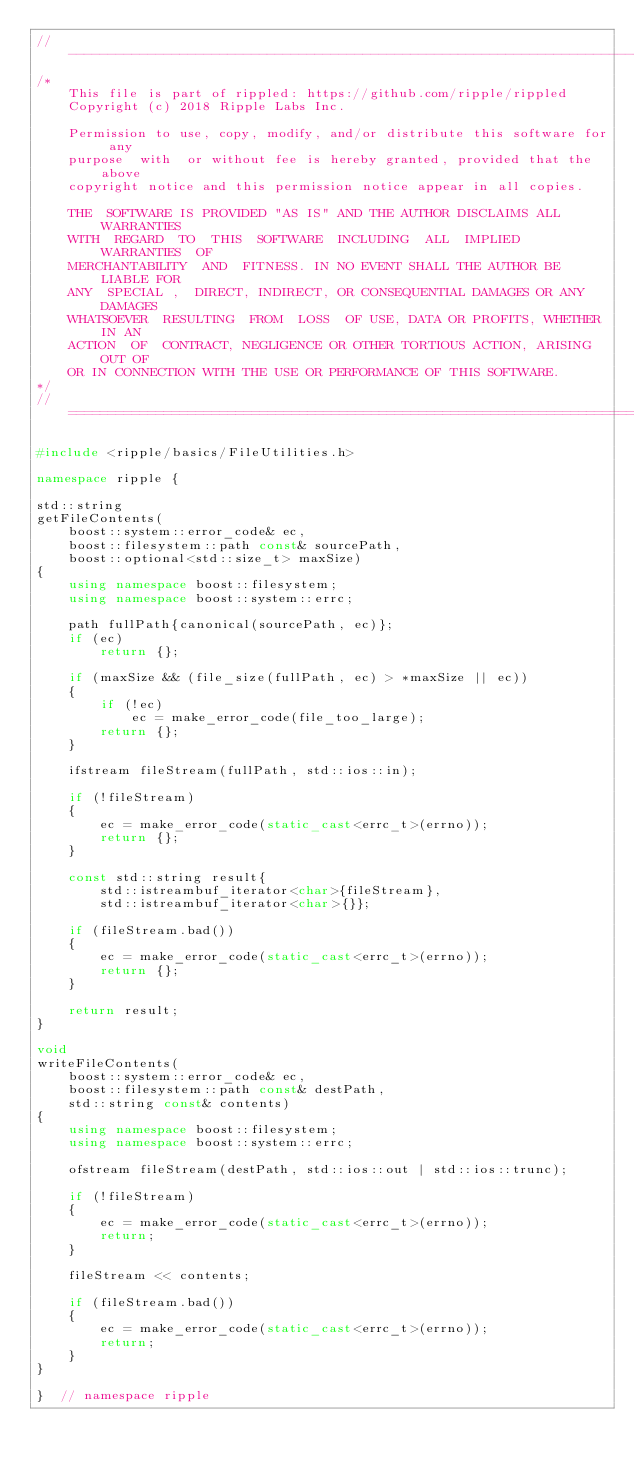<code> <loc_0><loc_0><loc_500><loc_500><_C++_>//------------------------------------------------------------------------------
/*
    This file is part of rippled: https://github.com/ripple/rippled
    Copyright (c) 2018 Ripple Labs Inc.

    Permission to use, copy, modify, and/or distribute this software for any
    purpose  with  or without fee is hereby granted, provided that the above
    copyright notice and this permission notice appear in all copies.

    THE  SOFTWARE IS PROVIDED "AS IS" AND THE AUTHOR DISCLAIMS ALL WARRANTIES
    WITH  REGARD  TO  THIS  SOFTWARE  INCLUDING  ALL  IMPLIED  WARRANTIES  OF
    MERCHANTABILITY  AND  FITNESS. IN NO EVENT SHALL THE AUTHOR BE LIABLE FOR
    ANY  SPECIAL ,  DIRECT, INDIRECT, OR CONSEQUENTIAL DAMAGES OR ANY DAMAGES
    WHATSOEVER  RESULTING  FROM  LOSS  OF USE, DATA OR PROFITS, WHETHER IN AN
    ACTION  OF  CONTRACT, NEGLIGENCE OR OTHER TORTIOUS ACTION, ARISING OUT OF
    OR IN CONNECTION WITH THE USE OR PERFORMANCE OF THIS SOFTWARE.
*/
//==============================================================================

#include <ripple/basics/FileUtilities.h>

namespace ripple {

std::string
getFileContents(
    boost::system::error_code& ec,
    boost::filesystem::path const& sourcePath,
    boost::optional<std::size_t> maxSize)
{
    using namespace boost::filesystem;
    using namespace boost::system::errc;

    path fullPath{canonical(sourcePath, ec)};
    if (ec)
        return {};

    if (maxSize && (file_size(fullPath, ec) > *maxSize || ec))
    {
        if (!ec)
            ec = make_error_code(file_too_large);
        return {};
    }

    ifstream fileStream(fullPath, std::ios::in);

    if (!fileStream)
    {
        ec = make_error_code(static_cast<errc_t>(errno));
        return {};
    }

    const std::string result{
        std::istreambuf_iterator<char>{fileStream},
        std::istreambuf_iterator<char>{}};

    if (fileStream.bad())
    {
        ec = make_error_code(static_cast<errc_t>(errno));
        return {};
    }

    return result;
}

void
writeFileContents(
    boost::system::error_code& ec,
    boost::filesystem::path const& destPath,
    std::string const& contents)
{
    using namespace boost::filesystem;
    using namespace boost::system::errc;

    ofstream fileStream(destPath, std::ios::out | std::ios::trunc);

    if (!fileStream)
    {
        ec = make_error_code(static_cast<errc_t>(errno));
        return;
    }

    fileStream << contents;

    if (fileStream.bad())
    {
        ec = make_error_code(static_cast<errc_t>(errno));
        return;
    }
}

}  // namespace ripple
</code> 